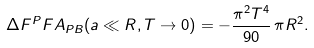<formula> <loc_0><loc_0><loc_500><loc_500>\Delta F ^ { P } F A _ { P B } ( a \ll R , T \rightarrow 0 ) = - \frac { \pi ^ { 2 } T ^ { 4 } } { 9 0 } \, \pi R ^ { 2 } .</formula> 